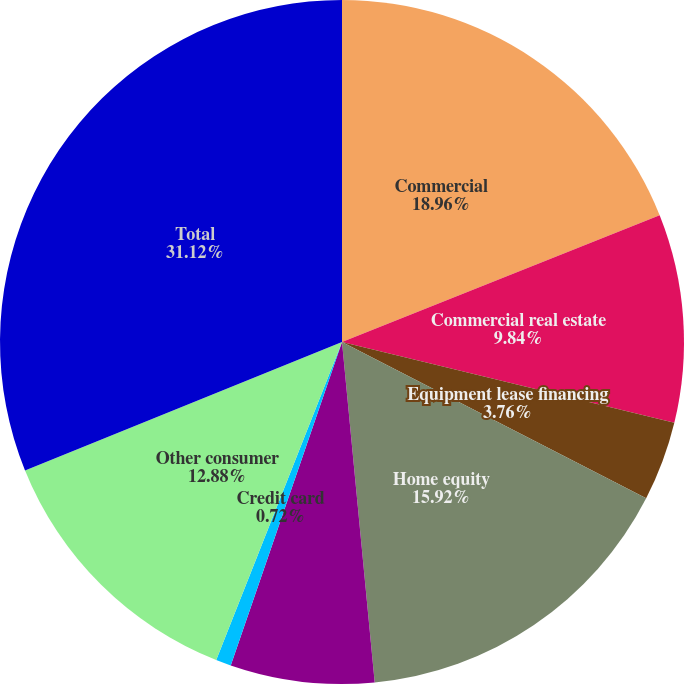<chart> <loc_0><loc_0><loc_500><loc_500><pie_chart><fcel>Commercial<fcel>Commercial real estate<fcel>Equipment lease financing<fcel>Home equity<fcel>Residential real estate<fcel>Credit card<fcel>Other consumer<fcel>Total<nl><fcel>18.96%<fcel>9.84%<fcel>3.76%<fcel>15.92%<fcel>6.8%<fcel>0.72%<fcel>12.88%<fcel>31.13%<nl></chart> 